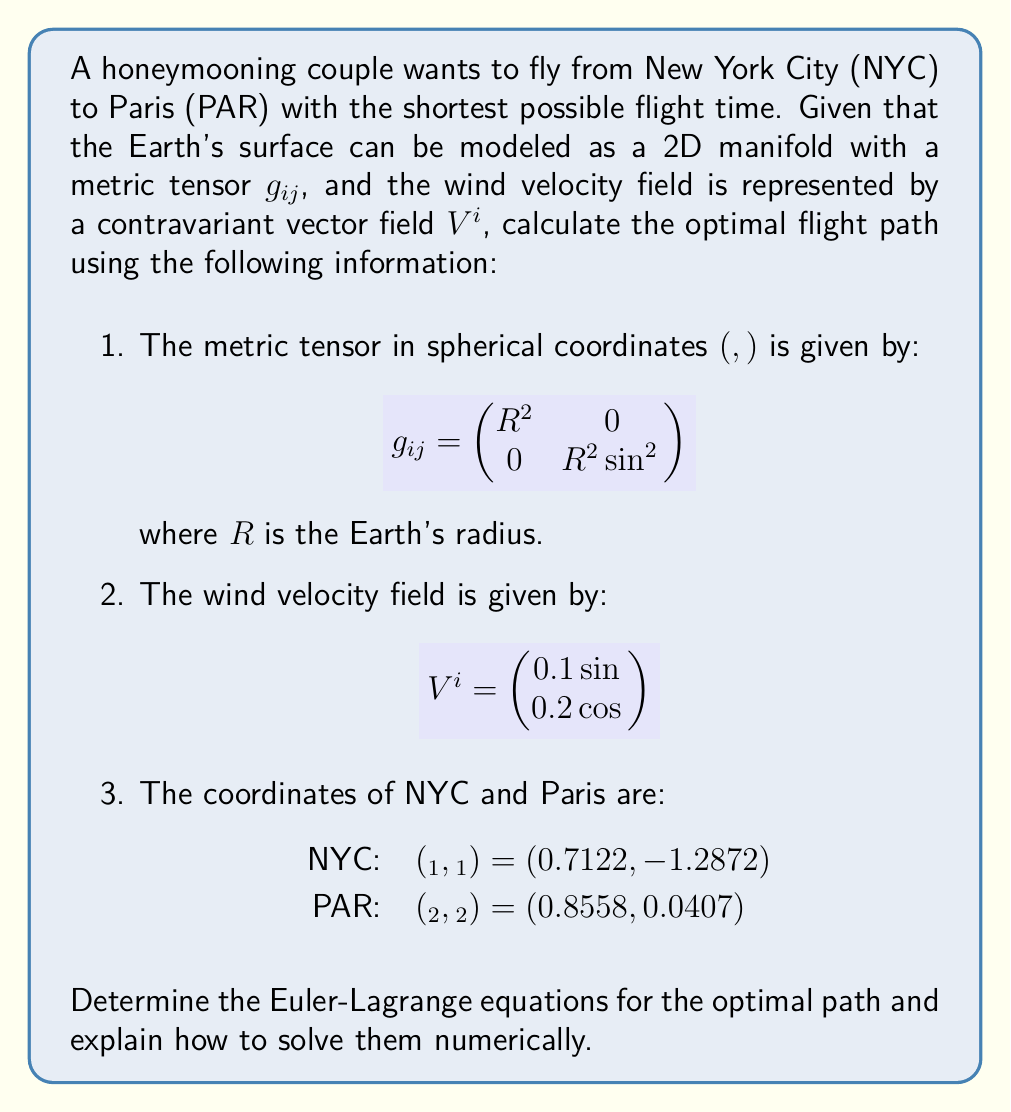Could you help me with this problem? To solve this problem, we need to follow these steps:

1. Set up the Lagrangian for the system:
   The Lagrangian $L$ represents the travel time and is given by:
   $$L = \frac{\sqrt{g_{ij}\frac{dx^i}{dt}\frac{dx^j}{dt}}}{1 + V^i\frac{dx^i}{dt}}$$

2. Express the Lagrangian in terms of spherical coordinates:
   $$L = \frac{\sqrt{R^2(\dot{θ}^2 + \sin^2 θ \dot{φ}^2)}}{1 + 0.1\sin φ \dot{θ} + 0.2\cos θ \dot{φ}}$$

3. Derive the Euler-Lagrange equations:
   The Euler-Lagrange equations are:
   $$\frac{d}{dt}\left(\frac{\partial L}{\partial \dot{q}_i}\right) - \frac{\partial L}{\partial q_i} = 0$$
   where $q_i$ represents $θ$ and $φ$.

4. Expand the Euler-Lagrange equations:
   For $θ$:
   $$\frac{d}{dt}\left(\frac{R^2\dot{θ}}{\sqrt{R^2(\dot{θ}^2 + \sin^2 θ \dot{φ}^2)}(1 + 0.1\sin φ \dot{θ} + 0.2\cos θ \dot{φ})}\right) - \frac{\partial L}{\partial θ} = 0$$

   For $φ$:
   $$\frac{d}{dt}\left(\frac{R^2\sin^2 θ \dot{φ}}{\sqrt{R^2(\dot{θ}^2 + \sin^2 θ \dot{φ}^2)}(1 + 0.1\sin φ \dot{θ} + 0.2\cos θ \dot{φ})}\right) - \frac{\partial L}{\partial φ} = 0$$

5. Solve the equations numerically:
   To solve these equations numerically, we can use a method such as the Runge-Kutta method or a variational approach. The steps would be:
   a. Discretize the path into $N$ points.
   b. Set up initial conditions using the great circle path between NYC and Paris.
   c. Iteratively update the path points to minimize the total travel time.
   d. Apply boundary conditions: $(θ_1, φ_1)$ for NYC and $(θ_2, φ_2)$ for Paris.
   e. Continue iterations until convergence is reached.

6. Interpret the results:
   The solution will give us a series of points $(θ_i, φ_i)$ representing the optimal flight path between NYC and Paris, taking into account the Earth's curvature and wind patterns.
Answer: Euler-Lagrange equations for $θ$ and $φ$, solved numerically using iterative methods. 